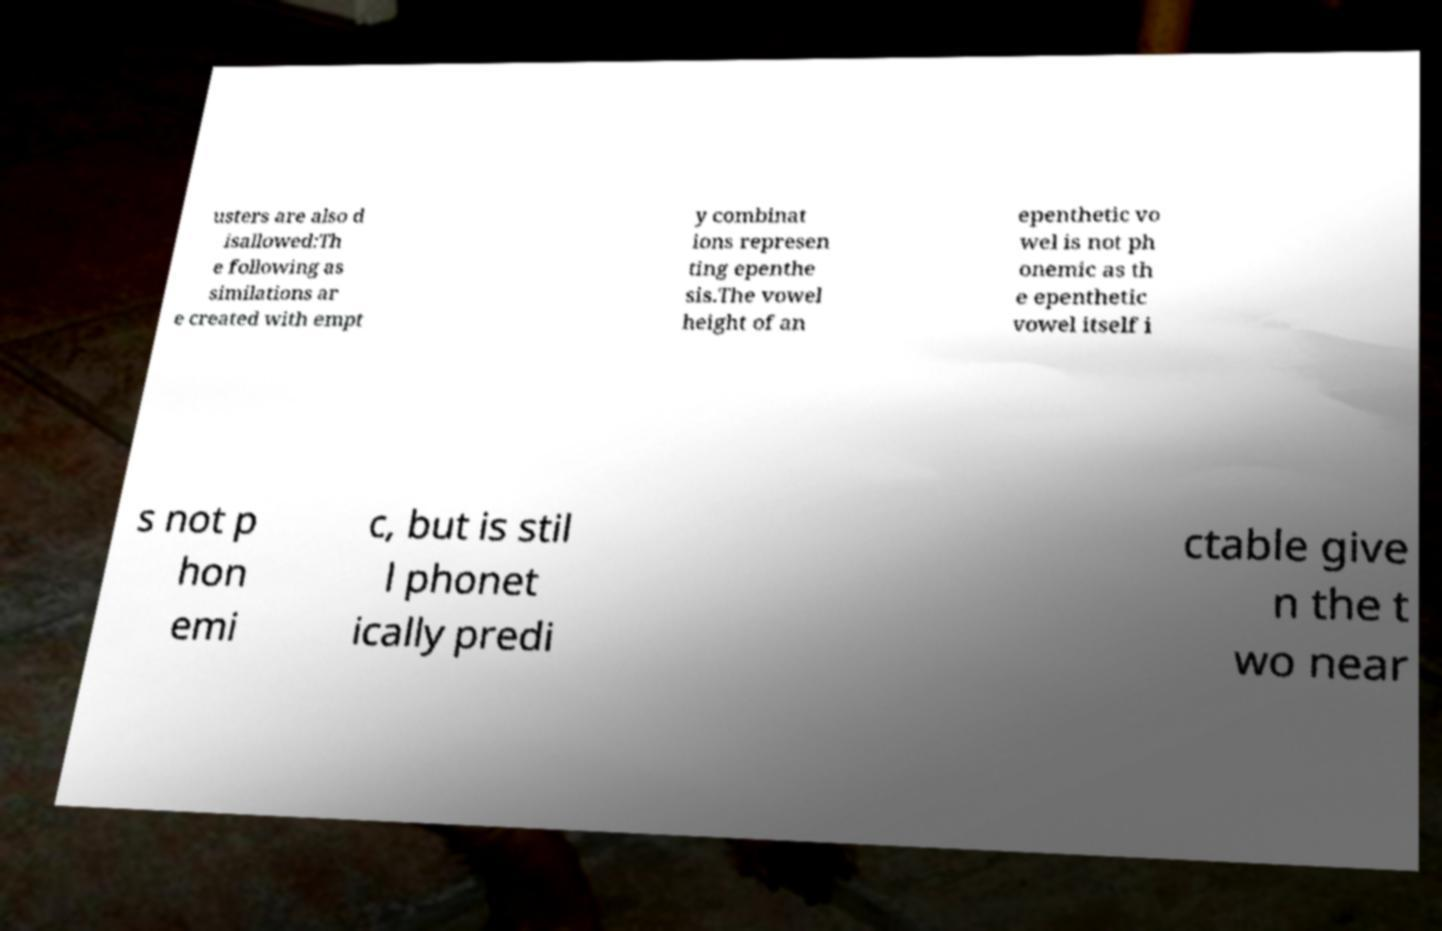There's text embedded in this image that I need extracted. Can you transcribe it verbatim? usters are also d isallowed:Th e following as similations ar e created with empt y combinat ions represen ting epenthe sis.The vowel height of an epenthetic vo wel is not ph onemic as th e epenthetic vowel itself i s not p hon emi c, but is stil l phonet ically predi ctable give n the t wo near 